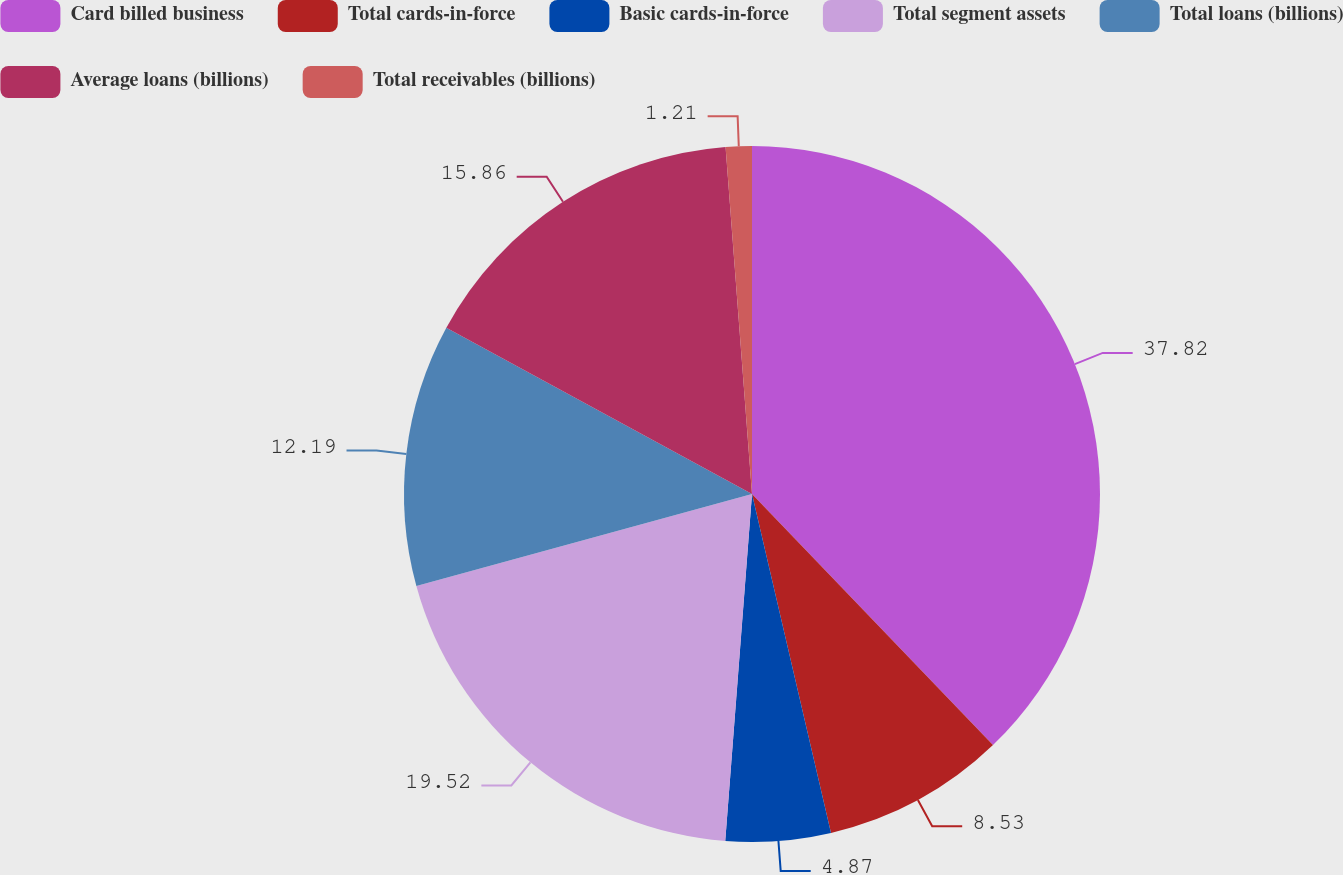<chart> <loc_0><loc_0><loc_500><loc_500><pie_chart><fcel>Card billed business<fcel>Total cards-in-force<fcel>Basic cards-in-force<fcel>Total segment assets<fcel>Total loans (billions)<fcel>Average loans (billions)<fcel>Total receivables (billions)<nl><fcel>37.83%<fcel>8.53%<fcel>4.87%<fcel>19.52%<fcel>12.19%<fcel>15.86%<fcel>1.21%<nl></chart> 